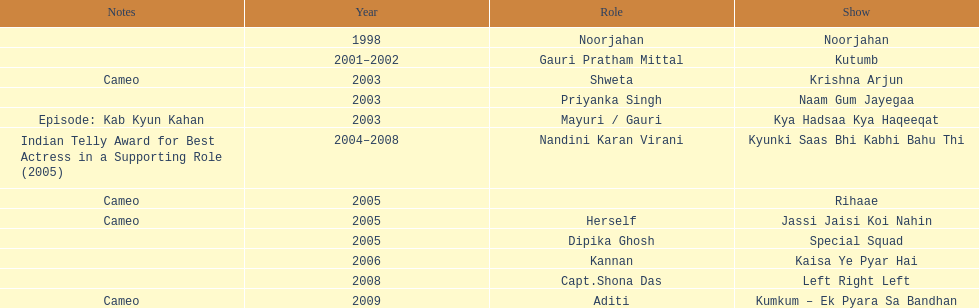Which was the only television show gauri starred in, in which she played herself? Jassi Jaisi Koi Nahin. 